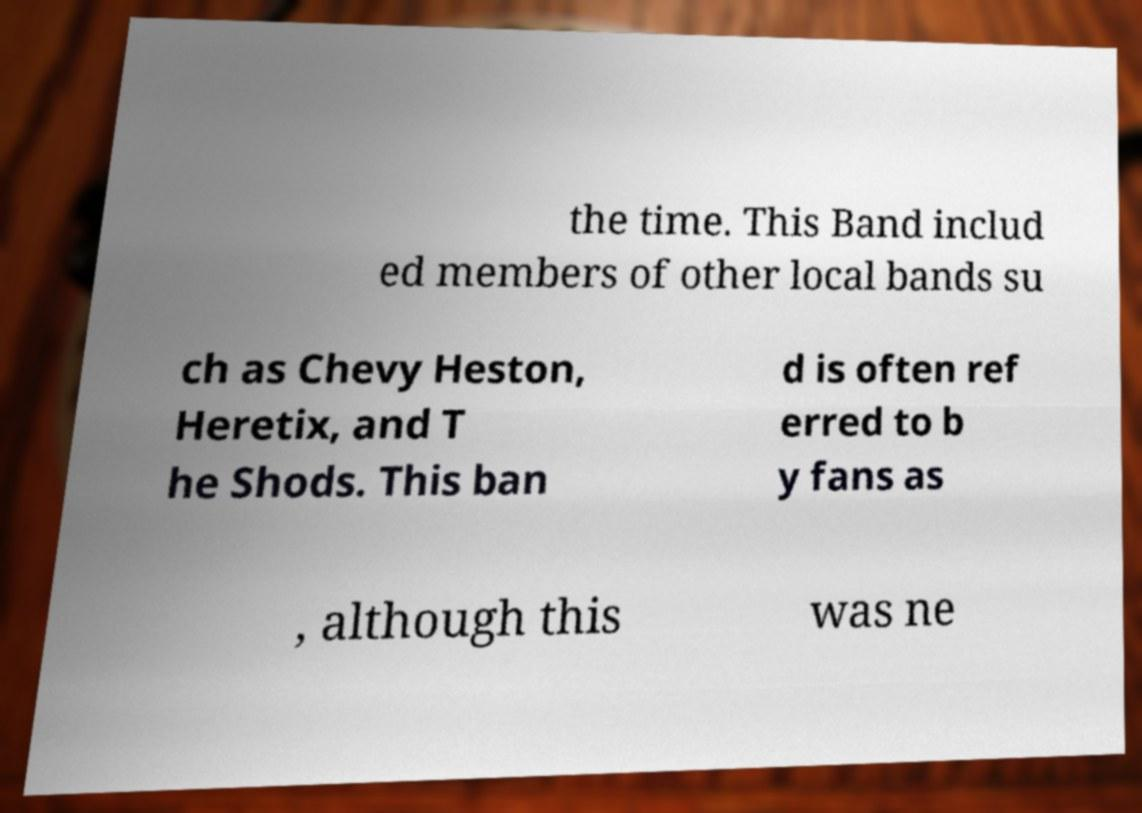I need the written content from this picture converted into text. Can you do that? the time. This Band includ ed members of other local bands su ch as Chevy Heston, Heretix, and T he Shods. This ban d is often ref erred to b y fans as , although this was ne 